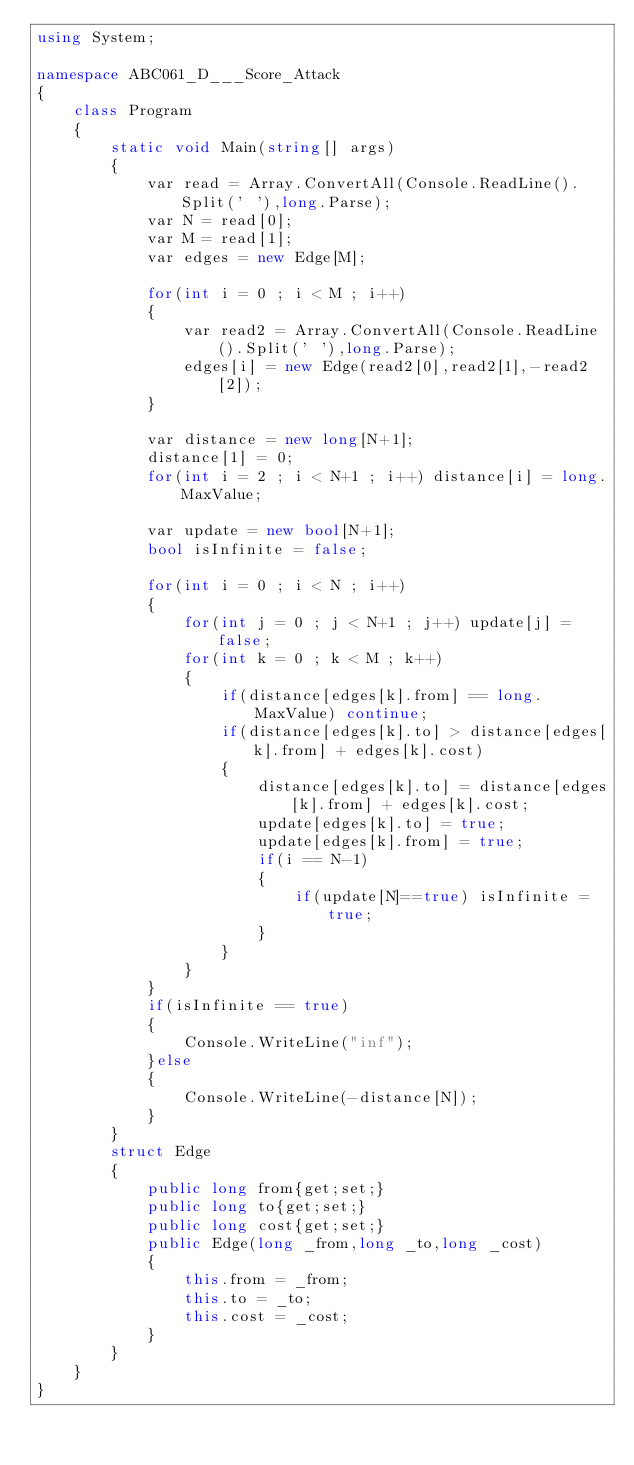<code> <loc_0><loc_0><loc_500><loc_500><_C#_>using System;

namespace ABC061_D___Score_Attack
{
    class Program
    {
        static void Main(string[] args)
        {
            var read = Array.ConvertAll(Console.ReadLine().Split(' '),long.Parse);
            var N = read[0];
            var M = read[1];
            var edges = new Edge[M];

            for(int i = 0 ; i < M ; i++)
            {
                var read2 = Array.ConvertAll(Console.ReadLine().Split(' '),long.Parse);
                edges[i] = new Edge(read2[0],read2[1],-read2[2]);
            }

            var distance = new long[N+1];
            distance[1] = 0;
            for(int i = 2 ; i < N+1 ; i++) distance[i] = long.MaxValue;

            var update = new bool[N+1];
            bool isInfinite = false;
            
            for(int i = 0 ; i < N ; i++)
            {
                for(int j = 0 ; j < N+1 ; j++) update[j] = false;
                for(int k = 0 ; k < M ; k++)
                {
                    if(distance[edges[k].from] == long.MaxValue) continue;
                    if(distance[edges[k].to] > distance[edges[k].from] + edges[k].cost)
                    {
                        distance[edges[k].to] = distance[edges[k].from] + edges[k].cost;
                        update[edges[k].to] = true;
                        update[edges[k].from] = true;
                        if(i == N-1)
                        {
                            if(update[N]==true) isInfinite = true;
                        }
                    }
                }
            }
            if(isInfinite == true)
            {
                Console.WriteLine("inf");
            }else
            {
                Console.WriteLine(-distance[N]);
            }
        }
        struct Edge
        {
            public long from{get;set;}
            public long to{get;set;}
            public long cost{get;set;}
            public Edge(long _from,long _to,long _cost)
            {
                this.from = _from;
                this.to = _to;
                this.cost = _cost;
            }
        }
    }
}
</code> 